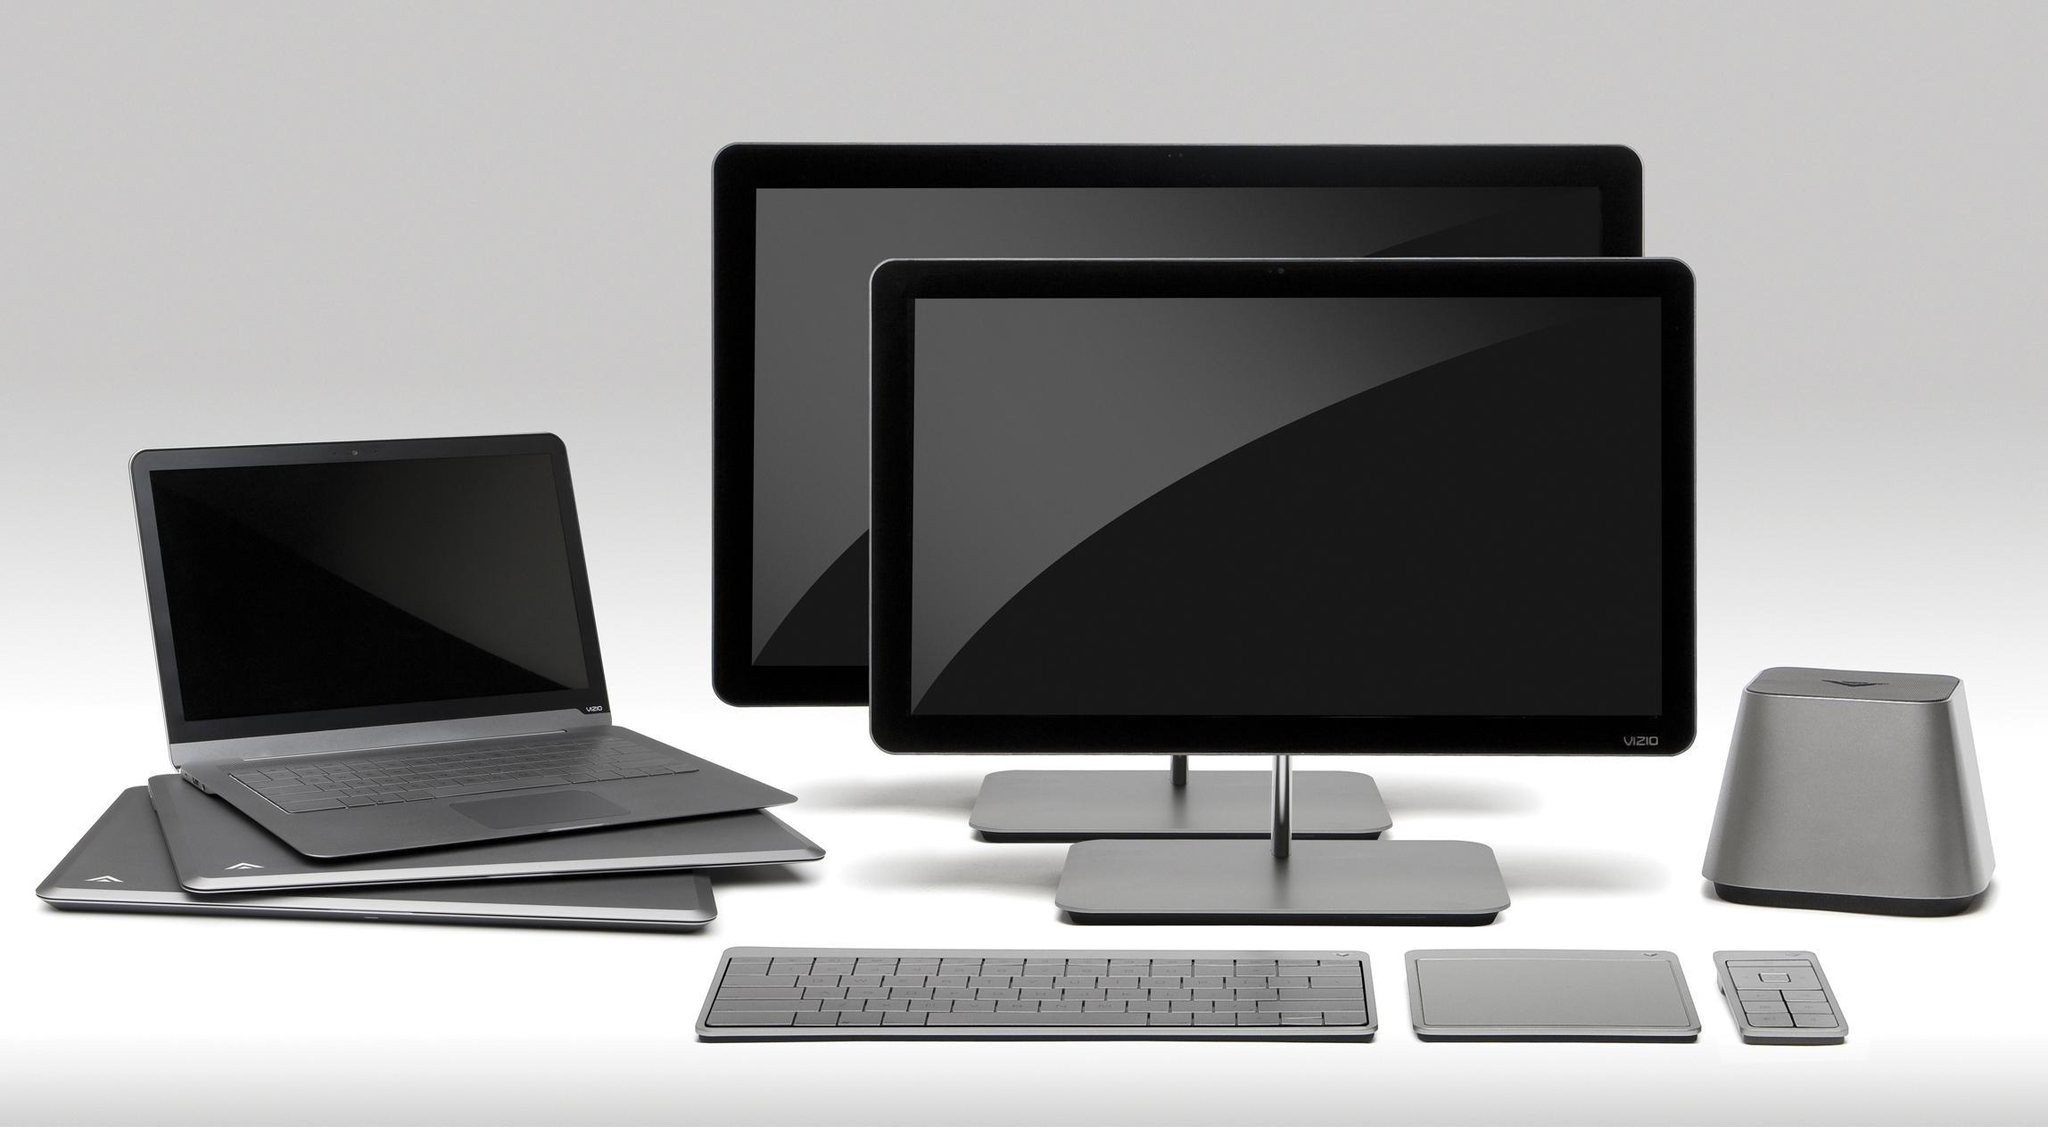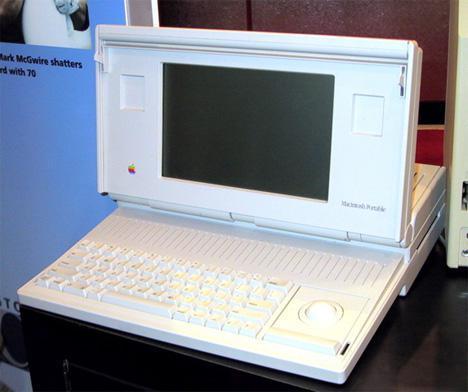The first image is the image on the left, the second image is the image on the right. For the images displayed, is the sentence "One image shows a suite of devices on a plain background." factually correct? Answer yes or no. Yes. 